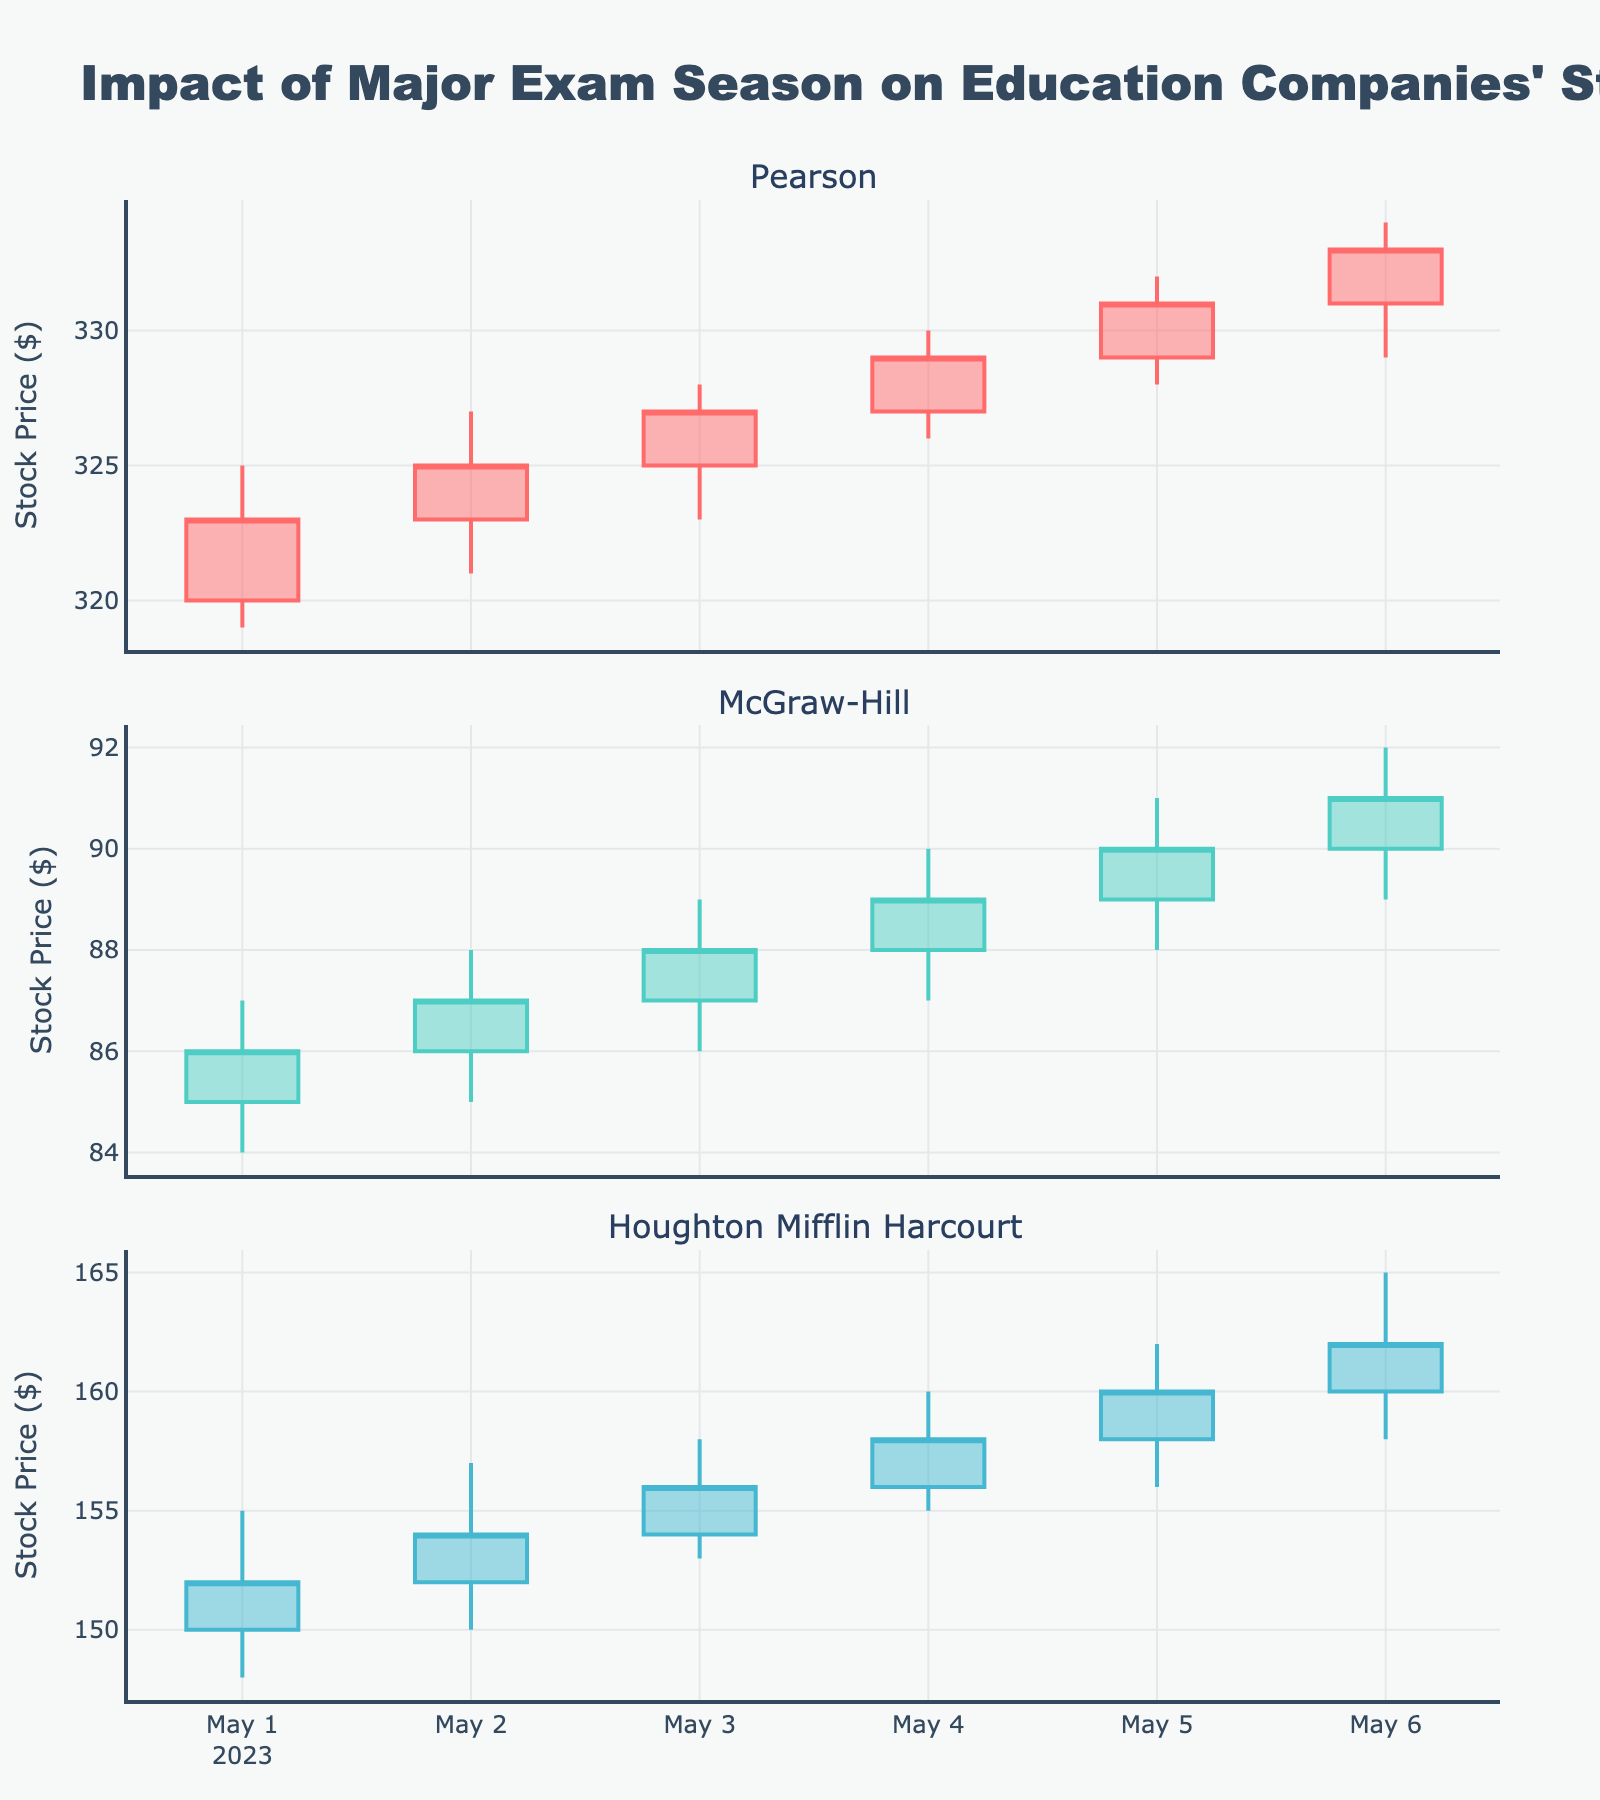Which company has the highest closing stock price on May 6? Examine the closing stock prices for each company on May 6. Pearson closes at 333, McGraw-Hill closes at 91, and Houghton Mifflin Harcourt closes at 162.
Answer: Pearson How does Pearson's stock price trend over the given period? Look at the candlestick visuals for Pearson from May 1 to May 6. Notice the trend of the closing prices, which generally increase from 323 to 333.
Answer: Increasing What is the approximate average volume for McGraw-Hill over the given period? Add the daily volumes for McGraw-Hill: 800000 + 850000 + 900000 + 900000 + 950000 + 990000 = 5390000. Divide by the number of days (6): 5390000 / 6 ≈ 898333.
Answer: 898333 Which day had the highest trading volume for Pearson, and what was the volume? Check the volume for each day for Pearson. The highest volume is on May 6 with 1700000.
Answer: May 6, 1700000 Compare the stock price increase for McGraw-Hill and Houghton Mifflin Harcourt from May 1 to May 6. Which company experienced a greater increase? Calculate the difference between the closing prices on May 6 and May 1 for both companies: McGraw-Hill (91 - 86 = 5) and Houghton Mifflin Harcourt (162 - 152 = 10). Houghton Mifflin Harcourt experienced a greater increase.
Answer: Houghton Mifflin Harcourt On which day did Pearson's stock price see the biggest single-day increase in its closing price? Compare the day-to-day closing prices for Pearson. The largest increase is from May 5 to May 6 (331 to 333).
Answer: May 6 Which company had the most significant low-to-high price range on May 3? Check the high and low prices for each company on May 3: Pearson (328 - 323 = 5), McGraw-Hill (89 - 86 = 3), Houghton Mifflin Harcourt (158 - 153 = 5). Both Pearson and Houghton Mifflin Harcourt have the same range.
Answer: Pearson and Houghton Mifflin Harcourt Which company's stock experienced the most consistent increase in its closing prices over the period? Look at the closing prices over the days for consistency. McGraw-Hill consistently increases daily from 86 to 91.
Answer: McGraw-Hill What was the lowest closing stock price recorded among the three companies over the given period? Find the minimum closing price among all the companies: Pearson (323), McGraw-Hill (86), Houghton Mifflin Harcourt (152). The lowest is 86 for McGraw-Hill.
Answer: McGraw-Hill (86) How did the trading volume for Houghton Mifflin Harcourt change from May 1 to May 6? Look at the trading volume for Houghton Mifflin Harcourt from 600000 on May 1 to 650000 on May 6.
Answer: Increased 